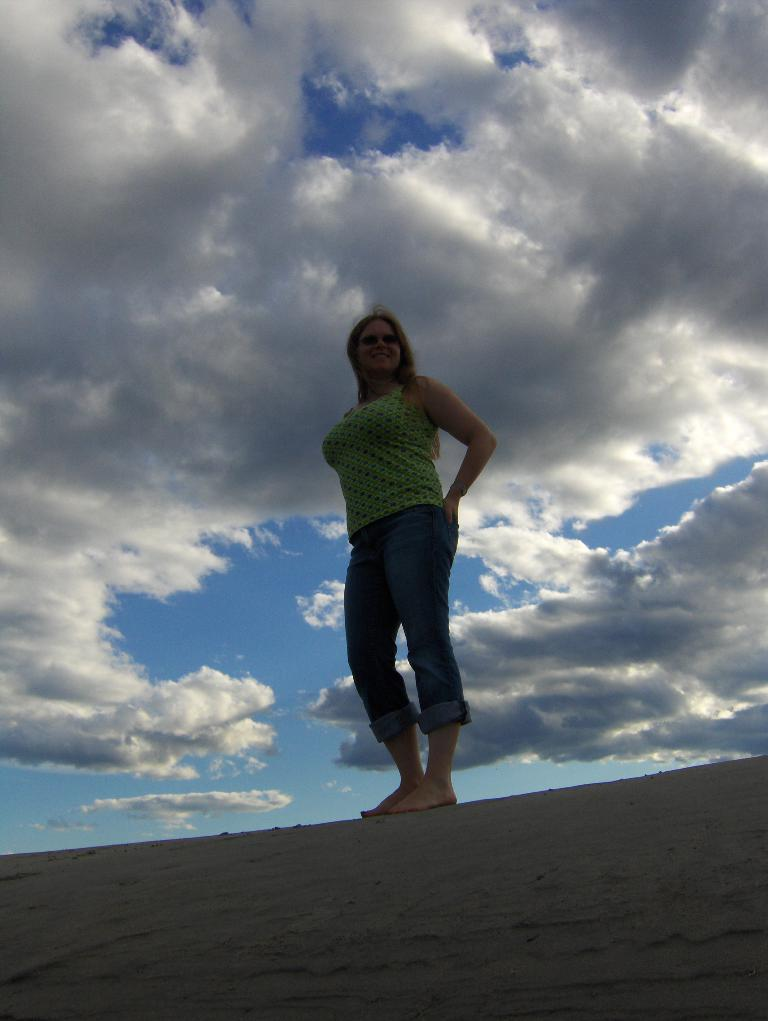Where was the picture taken? The picture was clicked outside. Who is present in the image? There is a woman in the image. What is the woman wearing? The woman is wearing a t-shirt. What is the woman's position in the image? The woman is standing on the ground. What can be seen in the background of the image? The sky is visible in the background of the image. What is the condition of the sky in the image? The sky is full of clouds. What type of hammer can be seen in the woman's hand in the image? There is no hammer present in the image. Is there a turkey visible in the background of the image? There is no turkey present in the image. 